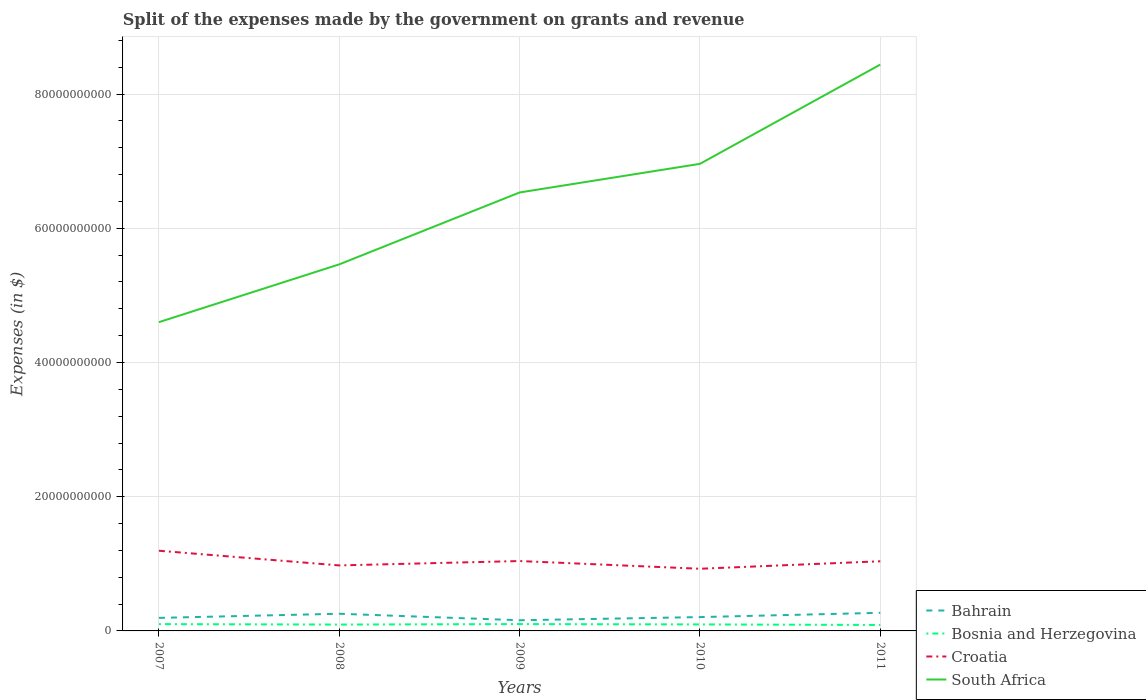Does the line corresponding to Bahrain intersect with the line corresponding to South Africa?
Offer a terse response. No. Is the number of lines equal to the number of legend labels?
Your answer should be compact. Yes. Across all years, what is the maximum expenses made by the government on grants and revenue in Bosnia and Herzegovina?
Ensure brevity in your answer.  8.87e+08. What is the total expenses made by the government on grants and revenue in Croatia in the graph?
Provide a succinct answer. 4.98e+08. What is the difference between the highest and the second highest expenses made by the government on grants and revenue in Croatia?
Make the answer very short. 2.69e+09. What is the difference between the highest and the lowest expenses made by the government on grants and revenue in Bahrain?
Your answer should be very brief. 2. How many years are there in the graph?
Provide a short and direct response. 5. What is the difference between two consecutive major ticks on the Y-axis?
Offer a terse response. 2.00e+1. Does the graph contain any zero values?
Provide a short and direct response. No. Does the graph contain grids?
Ensure brevity in your answer.  Yes. How are the legend labels stacked?
Provide a short and direct response. Vertical. What is the title of the graph?
Your answer should be compact. Split of the expenses made by the government on grants and revenue. Does "Saudi Arabia" appear as one of the legend labels in the graph?
Provide a succinct answer. No. What is the label or title of the Y-axis?
Provide a succinct answer. Expenses (in $). What is the Expenses (in $) in Bahrain in 2007?
Offer a terse response. 1.94e+09. What is the Expenses (in $) of Bosnia and Herzegovina in 2007?
Offer a terse response. 1.02e+09. What is the Expenses (in $) in Croatia in 2007?
Provide a succinct answer. 1.19e+1. What is the Expenses (in $) of South Africa in 2007?
Your response must be concise. 4.60e+1. What is the Expenses (in $) of Bahrain in 2008?
Your answer should be very brief. 2.56e+09. What is the Expenses (in $) in Bosnia and Herzegovina in 2008?
Provide a succinct answer. 9.49e+08. What is the Expenses (in $) of Croatia in 2008?
Provide a succinct answer. 9.76e+09. What is the Expenses (in $) in South Africa in 2008?
Provide a succinct answer. 5.46e+1. What is the Expenses (in $) in Bahrain in 2009?
Offer a terse response. 1.59e+09. What is the Expenses (in $) in Bosnia and Herzegovina in 2009?
Your answer should be compact. 1.02e+09. What is the Expenses (in $) in Croatia in 2009?
Your response must be concise. 1.04e+1. What is the Expenses (in $) of South Africa in 2009?
Provide a succinct answer. 6.53e+1. What is the Expenses (in $) of Bahrain in 2010?
Offer a very short reply. 2.06e+09. What is the Expenses (in $) of Bosnia and Herzegovina in 2010?
Offer a very short reply. 9.70e+08. What is the Expenses (in $) of Croatia in 2010?
Make the answer very short. 9.26e+09. What is the Expenses (in $) of South Africa in 2010?
Provide a succinct answer. 6.96e+1. What is the Expenses (in $) in Bahrain in 2011?
Provide a short and direct response. 2.70e+09. What is the Expenses (in $) in Bosnia and Herzegovina in 2011?
Provide a short and direct response. 8.87e+08. What is the Expenses (in $) in Croatia in 2011?
Your answer should be compact. 1.04e+1. What is the Expenses (in $) in South Africa in 2011?
Your response must be concise. 8.44e+1. Across all years, what is the maximum Expenses (in $) of Bahrain?
Your answer should be very brief. 2.70e+09. Across all years, what is the maximum Expenses (in $) of Bosnia and Herzegovina?
Ensure brevity in your answer.  1.02e+09. Across all years, what is the maximum Expenses (in $) in Croatia?
Your response must be concise. 1.19e+1. Across all years, what is the maximum Expenses (in $) of South Africa?
Your answer should be compact. 8.44e+1. Across all years, what is the minimum Expenses (in $) of Bahrain?
Ensure brevity in your answer.  1.59e+09. Across all years, what is the minimum Expenses (in $) of Bosnia and Herzegovina?
Keep it short and to the point. 8.87e+08. Across all years, what is the minimum Expenses (in $) of Croatia?
Make the answer very short. 9.26e+09. Across all years, what is the minimum Expenses (in $) in South Africa?
Ensure brevity in your answer.  4.60e+1. What is the total Expenses (in $) of Bahrain in the graph?
Your answer should be compact. 1.09e+1. What is the total Expenses (in $) of Bosnia and Herzegovina in the graph?
Offer a very short reply. 4.84e+09. What is the total Expenses (in $) in Croatia in the graph?
Your answer should be very brief. 5.18e+1. What is the total Expenses (in $) in South Africa in the graph?
Give a very brief answer. 3.20e+11. What is the difference between the Expenses (in $) in Bahrain in 2007 and that in 2008?
Your response must be concise. -6.15e+08. What is the difference between the Expenses (in $) of Bosnia and Herzegovina in 2007 and that in 2008?
Keep it short and to the point. 6.70e+07. What is the difference between the Expenses (in $) of Croatia in 2007 and that in 2008?
Your response must be concise. 2.19e+09. What is the difference between the Expenses (in $) of South Africa in 2007 and that in 2008?
Ensure brevity in your answer.  -8.61e+09. What is the difference between the Expenses (in $) of Bahrain in 2007 and that in 2009?
Keep it short and to the point. 3.53e+08. What is the difference between the Expenses (in $) of Bosnia and Herzegovina in 2007 and that in 2009?
Make the answer very short. -5.71e+06. What is the difference between the Expenses (in $) in Croatia in 2007 and that in 2009?
Ensure brevity in your answer.  1.53e+09. What is the difference between the Expenses (in $) of South Africa in 2007 and that in 2009?
Provide a succinct answer. -1.93e+1. What is the difference between the Expenses (in $) of Bahrain in 2007 and that in 2010?
Your response must be concise. -1.19e+08. What is the difference between the Expenses (in $) of Bosnia and Herzegovina in 2007 and that in 2010?
Provide a short and direct response. 4.64e+07. What is the difference between the Expenses (in $) of Croatia in 2007 and that in 2010?
Your answer should be very brief. 2.69e+09. What is the difference between the Expenses (in $) of South Africa in 2007 and that in 2010?
Give a very brief answer. -2.36e+1. What is the difference between the Expenses (in $) in Bahrain in 2007 and that in 2011?
Your answer should be very brief. -7.55e+08. What is the difference between the Expenses (in $) of Bosnia and Herzegovina in 2007 and that in 2011?
Offer a very short reply. 1.29e+08. What is the difference between the Expenses (in $) in Croatia in 2007 and that in 2011?
Your answer should be very brief. 1.57e+09. What is the difference between the Expenses (in $) of South Africa in 2007 and that in 2011?
Provide a short and direct response. -3.84e+1. What is the difference between the Expenses (in $) of Bahrain in 2008 and that in 2009?
Offer a very short reply. 9.68e+08. What is the difference between the Expenses (in $) of Bosnia and Herzegovina in 2008 and that in 2009?
Provide a short and direct response. -7.27e+07. What is the difference between the Expenses (in $) of Croatia in 2008 and that in 2009?
Your answer should be very brief. -6.52e+08. What is the difference between the Expenses (in $) in South Africa in 2008 and that in 2009?
Your response must be concise. -1.07e+1. What is the difference between the Expenses (in $) in Bahrain in 2008 and that in 2010?
Your answer should be compact. 4.96e+08. What is the difference between the Expenses (in $) in Bosnia and Herzegovina in 2008 and that in 2010?
Your answer should be very brief. -2.06e+07. What is the difference between the Expenses (in $) in Croatia in 2008 and that in 2010?
Offer a terse response. 4.98e+08. What is the difference between the Expenses (in $) of South Africa in 2008 and that in 2010?
Your response must be concise. -1.50e+1. What is the difference between the Expenses (in $) of Bahrain in 2008 and that in 2011?
Offer a terse response. -1.40e+08. What is the difference between the Expenses (in $) in Bosnia and Herzegovina in 2008 and that in 2011?
Give a very brief answer. 6.24e+07. What is the difference between the Expenses (in $) of Croatia in 2008 and that in 2011?
Your answer should be compact. -6.18e+08. What is the difference between the Expenses (in $) of South Africa in 2008 and that in 2011?
Ensure brevity in your answer.  -2.98e+1. What is the difference between the Expenses (in $) in Bahrain in 2009 and that in 2010?
Offer a very short reply. -4.71e+08. What is the difference between the Expenses (in $) in Bosnia and Herzegovina in 2009 and that in 2010?
Provide a succinct answer. 5.21e+07. What is the difference between the Expenses (in $) of Croatia in 2009 and that in 2010?
Your answer should be very brief. 1.15e+09. What is the difference between the Expenses (in $) in South Africa in 2009 and that in 2010?
Your response must be concise. -4.27e+09. What is the difference between the Expenses (in $) of Bahrain in 2009 and that in 2011?
Give a very brief answer. -1.11e+09. What is the difference between the Expenses (in $) of Bosnia and Herzegovina in 2009 and that in 2011?
Your response must be concise. 1.35e+08. What is the difference between the Expenses (in $) of Croatia in 2009 and that in 2011?
Provide a succinct answer. 3.44e+07. What is the difference between the Expenses (in $) of South Africa in 2009 and that in 2011?
Give a very brief answer. -1.91e+1. What is the difference between the Expenses (in $) in Bahrain in 2010 and that in 2011?
Your response must be concise. -6.37e+08. What is the difference between the Expenses (in $) in Bosnia and Herzegovina in 2010 and that in 2011?
Offer a very short reply. 8.30e+07. What is the difference between the Expenses (in $) of Croatia in 2010 and that in 2011?
Offer a very short reply. -1.12e+09. What is the difference between the Expenses (in $) in South Africa in 2010 and that in 2011?
Offer a terse response. -1.48e+1. What is the difference between the Expenses (in $) in Bahrain in 2007 and the Expenses (in $) in Bosnia and Herzegovina in 2008?
Make the answer very short. 9.94e+08. What is the difference between the Expenses (in $) of Bahrain in 2007 and the Expenses (in $) of Croatia in 2008?
Ensure brevity in your answer.  -7.82e+09. What is the difference between the Expenses (in $) of Bahrain in 2007 and the Expenses (in $) of South Africa in 2008?
Ensure brevity in your answer.  -5.27e+1. What is the difference between the Expenses (in $) of Bosnia and Herzegovina in 2007 and the Expenses (in $) of Croatia in 2008?
Your answer should be very brief. -8.74e+09. What is the difference between the Expenses (in $) of Bosnia and Herzegovina in 2007 and the Expenses (in $) of South Africa in 2008?
Offer a terse response. -5.36e+1. What is the difference between the Expenses (in $) of Croatia in 2007 and the Expenses (in $) of South Africa in 2008?
Offer a very short reply. -4.27e+1. What is the difference between the Expenses (in $) of Bahrain in 2007 and the Expenses (in $) of Bosnia and Herzegovina in 2009?
Make the answer very short. 9.21e+08. What is the difference between the Expenses (in $) of Bahrain in 2007 and the Expenses (in $) of Croatia in 2009?
Provide a short and direct response. -8.47e+09. What is the difference between the Expenses (in $) of Bahrain in 2007 and the Expenses (in $) of South Africa in 2009?
Provide a short and direct response. -6.34e+1. What is the difference between the Expenses (in $) of Bosnia and Herzegovina in 2007 and the Expenses (in $) of Croatia in 2009?
Make the answer very short. -9.40e+09. What is the difference between the Expenses (in $) of Bosnia and Herzegovina in 2007 and the Expenses (in $) of South Africa in 2009?
Make the answer very short. -6.43e+1. What is the difference between the Expenses (in $) in Croatia in 2007 and the Expenses (in $) in South Africa in 2009?
Your answer should be compact. -5.34e+1. What is the difference between the Expenses (in $) of Bahrain in 2007 and the Expenses (in $) of Bosnia and Herzegovina in 2010?
Keep it short and to the point. 9.73e+08. What is the difference between the Expenses (in $) in Bahrain in 2007 and the Expenses (in $) in Croatia in 2010?
Provide a succinct answer. -7.32e+09. What is the difference between the Expenses (in $) of Bahrain in 2007 and the Expenses (in $) of South Africa in 2010?
Your response must be concise. -6.77e+1. What is the difference between the Expenses (in $) in Bosnia and Herzegovina in 2007 and the Expenses (in $) in Croatia in 2010?
Provide a short and direct response. -8.25e+09. What is the difference between the Expenses (in $) of Bosnia and Herzegovina in 2007 and the Expenses (in $) of South Africa in 2010?
Your response must be concise. -6.86e+1. What is the difference between the Expenses (in $) in Croatia in 2007 and the Expenses (in $) in South Africa in 2010?
Your response must be concise. -5.77e+1. What is the difference between the Expenses (in $) in Bahrain in 2007 and the Expenses (in $) in Bosnia and Herzegovina in 2011?
Provide a succinct answer. 1.06e+09. What is the difference between the Expenses (in $) in Bahrain in 2007 and the Expenses (in $) in Croatia in 2011?
Your response must be concise. -8.44e+09. What is the difference between the Expenses (in $) of Bahrain in 2007 and the Expenses (in $) of South Africa in 2011?
Your answer should be very brief. -8.24e+1. What is the difference between the Expenses (in $) in Bosnia and Herzegovina in 2007 and the Expenses (in $) in Croatia in 2011?
Offer a very short reply. -9.36e+09. What is the difference between the Expenses (in $) in Bosnia and Herzegovina in 2007 and the Expenses (in $) in South Africa in 2011?
Your response must be concise. -8.34e+1. What is the difference between the Expenses (in $) in Croatia in 2007 and the Expenses (in $) in South Africa in 2011?
Provide a short and direct response. -7.24e+1. What is the difference between the Expenses (in $) of Bahrain in 2008 and the Expenses (in $) of Bosnia and Herzegovina in 2009?
Your answer should be compact. 1.54e+09. What is the difference between the Expenses (in $) in Bahrain in 2008 and the Expenses (in $) in Croatia in 2009?
Your answer should be compact. -7.86e+09. What is the difference between the Expenses (in $) in Bahrain in 2008 and the Expenses (in $) in South Africa in 2009?
Offer a terse response. -6.28e+1. What is the difference between the Expenses (in $) in Bosnia and Herzegovina in 2008 and the Expenses (in $) in Croatia in 2009?
Provide a succinct answer. -9.46e+09. What is the difference between the Expenses (in $) of Bosnia and Herzegovina in 2008 and the Expenses (in $) of South Africa in 2009?
Your response must be concise. -6.44e+1. What is the difference between the Expenses (in $) of Croatia in 2008 and the Expenses (in $) of South Africa in 2009?
Make the answer very short. -5.56e+1. What is the difference between the Expenses (in $) of Bahrain in 2008 and the Expenses (in $) of Bosnia and Herzegovina in 2010?
Keep it short and to the point. 1.59e+09. What is the difference between the Expenses (in $) in Bahrain in 2008 and the Expenses (in $) in Croatia in 2010?
Keep it short and to the point. -6.70e+09. What is the difference between the Expenses (in $) of Bahrain in 2008 and the Expenses (in $) of South Africa in 2010?
Your response must be concise. -6.70e+1. What is the difference between the Expenses (in $) in Bosnia and Herzegovina in 2008 and the Expenses (in $) in Croatia in 2010?
Provide a succinct answer. -8.31e+09. What is the difference between the Expenses (in $) in Bosnia and Herzegovina in 2008 and the Expenses (in $) in South Africa in 2010?
Provide a short and direct response. -6.86e+1. What is the difference between the Expenses (in $) in Croatia in 2008 and the Expenses (in $) in South Africa in 2010?
Give a very brief answer. -5.98e+1. What is the difference between the Expenses (in $) of Bahrain in 2008 and the Expenses (in $) of Bosnia and Herzegovina in 2011?
Provide a succinct answer. 1.67e+09. What is the difference between the Expenses (in $) of Bahrain in 2008 and the Expenses (in $) of Croatia in 2011?
Provide a succinct answer. -7.82e+09. What is the difference between the Expenses (in $) in Bahrain in 2008 and the Expenses (in $) in South Africa in 2011?
Make the answer very short. -8.18e+1. What is the difference between the Expenses (in $) of Bosnia and Herzegovina in 2008 and the Expenses (in $) of Croatia in 2011?
Your response must be concise. -9.43e+09. What is the difference between the Expenses (in $) in Bosnia and Herzegovina in 2008 and the Expenses (in $) in South Africa in 2011?
Make the answer very short. -8.34e+1. What is the difference between the Expenses (in $) of Croatia in 2008 and the Expenses (in $) of South Africa in 2011?
Provide a succinct answer. -7.46e+1. What is the difference between the Expenses (in $) of Bahrain in 2009 and the Expenses (in $) of Bosnia and Herzegovina in 2010?
Ensure brevity in your answer.  6.20e+08. What is the difference between the Expenses (in $) in Bahrain in 2009 and the Expenses (in $) in Croatia in 2010?
Provide a short and direct response. -7.67e+09. What is the difference between the Expenses (in $) in Bahrain in 2009 and the Expenses (in $) in South Africa in 2010?
Ensure brevity in your answer.  -6.80e+1. What is the difference between the Expenses (in $) in Bosnia and Herzegovina in 2009 and the Expenses (in $) in Croatia in 2010?
Provide a succinct answer. -8.24e+09. What is the difference between the Expenses (in $) in Bosnia and Herzegovina in 2009 and the Expenses (in $) in South Africa in 2010?
Provide a short and direct response. -6.86e+1. What is the difference between the Expenses (in $) in Croatia in 2009 and the Expenses (in $) in South Africa in 2010?
Offer a terse response. -5.92e+1. What is the difference between the Expenses (in $) of Bahrain in 2009 and the Expenses (in $) of Bosnia and Herzegovina in 2011?
Your response must be concise. 7.03e+08. What is the difference between the Expenses (in $) in Bahrain in 2009 and the Expenses (in $) in Croatia in 2011?
Keep it short and to the point. -8.79e+09. What is the difference between the Expenses (in $) in Bahrain in 2009 and the Expenses (in $) in South Africa in 2011?
Provide a succinct answer. -8.28e+1. What is the difference between the Expenses (in $) in Bosnia and Herzegovina in 2009 and the Expenses (in $) in Croatia in 2011?
Make the answer very short. -9.36e+09. What is the difference between the Expenses (in $) of Bosnia and Herzegovina in 2009 and the Expenses (in $) of South Africa in 2011?
Your answer should be very brief. -8.34e+1. What is the difference between the Expenses (in $) of Croatia in 2009 and the Expenses (in $) of South Africa in 2011?
Offer a very short reply. -7.40e+1. What is the difference between the Expenses (in $) of Bahrain in 2010 and the Expenses (in $) of Bosnia and Herzegovina in 2011?
Provide a short and direct response. 1.17e+09. What is the difference between the Expenses (in $) of Bahrain in 2010 and the Expenses (in $) of Croatia in 2011?
Your answer should be compact. -8.32e+09. What is the difference between the Expenses (in $) in Bahrain in 2010 and the Expenses (in $) in South Africa in 2011?
Provide a succinct answer. -8.23e+1. What is the difference between the Expenses (in $) of Bosnia and Herzegovina in 2010 and the Expenses (in $) of Croatia in 2011?
Your answer should be very brief. -9.41e+09. What is the difference between the Expenses (in $) of Bosnia and Herzegovina in 2010 and the Expenses (in $) of South Africa in 2011?
Provide a succinct answer. -8.34e+1. What is the difference between the Expenses (in $) in Croatia in 2010 and the Expenses (in $) in South Africa in 2011?
Give a very brief answer. -7.51e+1. What is the average Expenses (in $) in Bahrain per year?
Ensure brevity in your answer.  2.17e+09. What is the average Expenses (in $) in Bosnia and Herzegovina per year?
Offer a terse response. 9.69e+08. What is the average Expenses (in $) of Croatia per year?
Your answer should be very brief. 1.04e+1. What is the average Expenses (in $) of South Africa per year?
Give a very brief answer. 6.40e+1. In the year 2007, what is the difference between the Expenses (in $) in Bahrain and Expenses (in $) in Bosnia and Herzegovina?
Keep it short and to the point. 9.27e+08. In the year 2007, what is the difference between the Expenses (in $) of Bahrain and Expenses (in $) of Croatia?
Keep it short and to the point. -1.00e+1. In the year 2007, what is the difference between the Expenses (in $) in Bahrain and Expenses (in $) in South Africa?
Ensure brevity in your answer.  -4.41e+1. In the year 2007, what is the difference between the Expenses (in $) of Bosnia and Herzegovina and Expenses (in $) of Croatia?
Your answer should be compact. -1.09e+1. In the year 2007, what is the difference between the Expenses (in $) of Bosnia and Herzegovina and Expenses (in $) of South Africa?
Your answer should be compact. -4.50e+1. In the year 2007, what is the difference between the Expenses (in $) of Croatia and Expenses (in $) of South Africa?
Your answer should be very brief. -3.41e+1. In the year 2008, what is the difference between the Expenses (in $) in Bahrain and Expenses (in $) in Bosnia and Herzegovina?
Make the answer very short. 1.61e+09. In the year 2008, what is the difference between the Expenses (in $) in Bahrain and Expenses (in $) in Croatia?
Provide a short and direct response. -7.20e+09. In the year 2008, what is the difference between the Expenses (in $) of Bahrain and Expenses (in $) of South Africa?
Offer a very short reply. -5.21e+1. In the year 2008, what is the difference between the Expenses (in $) in Bosnia and Herzegovina and Expenses (in $) in Croatia?
Your answer should be compact. -8.81e+09. In the year 2008, what is the difference between the Expenses (in $) of Bosnia and Herzegovina and Expenses (in $) of South Africa?
Give a very brief answer. -5.37e+1. In the year 2008, what is the difference between the Expenses (in $) of Croatia and Expenses (in $) of South Africa?
Provide a succinct answer. -4.49e+1. In the year 2009, what is the difference between the Expenses (in $) of Bahrain and Expenses (in $) of Bosnia and Herzegovina?
Offer a very short reply. 5.68e+08. In the year 2009, what is the difference between the Expenses (in $) of Bahrain and Expenses (in $) of Croatia?
Provide a succinct answer. -8.82e+09. In the year 2009, what is the difference between the Expenses (in $) of Bahrain and Expenses (in $) of South Africa?
Provide a succinct answer. -6.37e+1. In the year 2009, what is the difference between the Expenses (in $) of Bosnia and Herzegovina and Expenses (in $) of Croatia?
Provide a succinct answer. -9.39e+09. In the year 2009, what is the difference between the Expenses (in $) in Bosnia and Herzegovina and Expenses (in $) in South Africa?
Your answer should be compact. -6.43e+1. In the year 2009, what is the difference between the Expenses (in $) in Croatia and Expenses (in $) in South Africa?
Ensure brevity in your answer.  -5.49e+1. In the year 2010, what is the difference between the Expenses (in $) in Bahrain and Expenses (in $) in Bosnia and Herzegovina?
Your answer should be very brief. 1.09e+09. In the year 2010, what is the difference between the Expenses (in $) in Bahrain and Expenses (in $) in Croatia?
Keep it short and to the point. -7.20e+09. In the year 2010, what is the difference between the Expenses (in $) of Bahrain and Expenses (in $) of South Africa?
Your answer should be compact. -6.75e+1. In the year 2010, what is the difference between the Expenses (in $) of Bosnia and Herzegovina and Expenses (in $) of Croatia?
Keep it short and to the point. -8.29e+09. In the year 2010, what is the difference between the Expenses (in $) in Bosnia and Herzegovina and Expenses (in $) in South Africa?
Offer a terse response. -6.86e+1. In the year 2010, what is the difference between the Expenses (in $) of Croatia and Expenses (in $) of South Africa?
Your answer should be compact. -6.03e+1. In the year 2011, what is the difference between the Expenses (in $) of Bahrain and Expenses (in $) of Bosnia and Herzegovina?
Offer a very short reply. 1.81e+09. In the year 2011, what is the difference between the Expenses (in $) of Bahrain and Expenses (in $) of Croatia?
Ensure brevity in your answer.  -7.68e+09. In the year 2011, what is the difference between the Expenses (in $) in Bahrain and Expenses (in $) in South Africa?
Keep it short and to the point. -8.17e+1. In the year 2011, what is the difference between the Expenses (in $) in Bosnia and Herzegovina and Expenses (in $) in Croatia?
Your answer should be compact. -9.49e+09. In the year 2011, what is the difference between the Expenses (in $) of Bosnia and Herzegovina and Expenses (in $) of South Africa?
Offer a terse response. -8.35e+1. In the year 2011, what is the difference between the Expenses (in $) in Croatia and Expenses (in $) in South Africa?
Keep it short and to the point. -7.40e+1. What is the ratio of the Expenses (in $) of Bahrain in 2007 to that in 2008?
Ensure brevity in your answer.  0.76. What is the ratio of the Expenses (in $) in Bosnia and Herzegovina in 2007 to that in 2008?
Provide a short and direct response. 1.07. What is the ratio of the Expenses (in $) in Croatia in 2007 to that in 2008?
Offer a very short reply. 1.22. What is the ratio of the Expenses (in $) of South Africa in 2007 to that in 2008?
Your response must be concise. 0.84. What is the ratio of the Expenses (in $) in Bahrain in 2007 to that in 2009?
Your answer should be very brief. 1.22. What is the ratio of the Expenses (in $) in Croatia in 2007 to that in 2009?
Your answer should be very brief. 1.15. What is the ratio of the Expenses (in $) of South Africa in 2007 to that in 2009?
Your answer should be compact. 0.7. What is the ratio of the Expenses (in $) of Bahrain in 2007 to that in 2010?
Your response must be concise. 0.94. What is the ratio of the Expenses (in $) of Bosnia and Herzegovina in 2007 to that in 2010?
Offer a terse response. 1.05. What is the ratio of the Expenses (in $) of Croatia in 2007 to that in 2010?
Keep it short and to the point. 1.29. What is the ratio of the Expenses (in $) of South Africa in 2007 to that in 2010?
Your answer should be very brief. 0.66. What is the ratio of the Expenses (in $) of Bahrain in 2007 to that in 2011?
Offer a terse response. 0.72. What is the ratio of the Expenses (in $) of Bosnia and Herzegovina in 2007 to that in 2011?
Offer a very short reply. 1.15. What is the ratio of the Expenses (in $) of Croatia in 2007 to that in 2011?
Your response must be concise. 1.15. What is the ratio of the Expenses (in $) in South Africa in 2007 to that in 2011?
Your response must be concise. 0.55. What is the ratio of the Expenses (in $) in Bahrain in 2008 to that in 2009?
Give a very brief answer. 1.61. What is the ratio of the Expenses (in $) of Bosnia and Herzegovina in 2008 to that in 2009?
Ensure brevity in your answer.  0.93. What is the ratio of the Expenses (in $) of Croatia in 2008 to that in 2009?
Ensure brevity in your answer.  0.94. What is the ratio of the Expenses (in $) of South Africa in 2008 to that in 2009?
Keep it short and to the point. 0.84. What is the ratio of the Expenses (in $) in Bahrain in 2008 to that in 2010?
Offer a very short reply. 1.24. What is the ratio of the Expenses (in $) in Bosnia and Herzegovina in 2008 to that in 2010?
Provide a succinct answer. 0.98. What is the ratio of the Expenses (in $) of Croatia in 2008 to that in 2010?
Your answer should be very brief. 1.05. What is the ratio of the Expenses (in $) of South Africa in 2008 to that in 2010?
Your answer should be very brief. 0.78. What is the ratio of the Expenses (in $) in Bahrain in 2008 to that in 2011?
Ensure brevity in your answer.  0.95. What is the ratio of the Expenses (in $) in Bosnia and Herzegovina in 2008 to that in 2011?
Offer a terse response. 1.07. What is the ratio of the Expenses (in $) in Croatia in 2008 to that in 2011?
Keep it short and to the point. 0.94. What is the ratio of the Expenses (in $) in South Africa in 2008 to that in 2011?
Provide a short and direct response. 0.65. What is the ratio of the Expenses (in $) of Bahrain in 2009 to that in 2010?
Provide a short and direct response. 0.77. What is the ratio of the Expenses (in $) of Bosnia and Herzegovina in 2009 to that in 2010?
Give a very brief answer. 1.05. What is the ratio of the Expenses (in $) in Croatia in 2009 to that in 2010?
Your answer should be very brief. 1.12. What is the ratio of the Expenses (in $) of South Africa in 2009 to that in 2010?
Your response must be concise. 0.94. What is the ratio of the Expenses (in $) of Bahrain in 2009 to that in 2011?
Your answer should be compact. 0.59. What is the ratio of the Expenses (in $) of Bosnia and Herzegovina in 2009 to that in 2011?
Ensure brevity in your answer.  1.15. What is the ratio of the Expenses (in $) of Croatia in 2009 to that in 2011?
Make the answer very short. 1. What is the ratio of the Expenses (in $) in South Africa in 2009 to that in 2011?
Your answer should be very brief. 0.77. What is the ratio of the Expenses (in $) in Bahrain in 2010 to that in 2011?
Offer a terse response. 0.76. What is the ratio of the Expenses (in $) of Bosnia and Herzegovina in 2010 to that in 2011?
Your response must be concise. 1.09. What is the ratio of the Expenses (in $) of Croatia in 2010 to that in 2011?
Provide a succinct answer. 0.89. What is the ratio of the Expenses (in $) of South Africa in 2010 to that in 2011?
Provide a succinct answer. 0.82. What is the difference between the highest and the second highest Expenses (in $) in Bahrain?
Provide a succinct answer. 1.40e+08. What is the difference between the highest and the second highest Expenses (in $) in Bosnia and Herzegovina?
Your response must be concise. 5.71e+06. What is the difference between the highest and the second highest Expenses (in $) in Croatia?
Provide a succinct answer. 1.53e+09. What is the difference between the highest and the second highest Expenses (in $) of South Africa?
Provide a short and direct response. 1.48e+1. What is the difference between the highest and the lowest Expenses (in $) of Bahrain?
Make the answer very short. 1.11e+09. What is the difference between the highest and the lowest Expenses (in $) of Bosnia and Herzegovina?
Give a very brief answer. 1.35e+08. What is the difference between the highest and the lowest Expenses (in $) of Croatia?
Your answer should be compact. 2.69e+09. What is the difference between the highest and the lowest Expenses (in $) in South Africa?
Offer a terse response. 3.84e+1. 